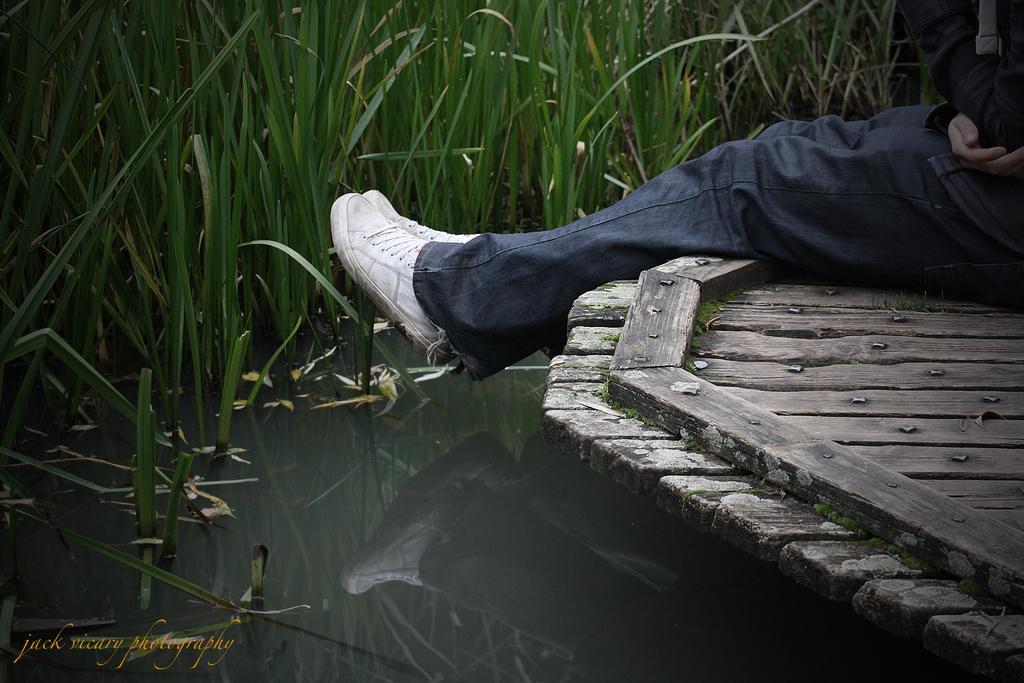Describe this image in one or two sentences. In the image I can see a lake in which there are some plants and to the side there is a person on the wooden path. 